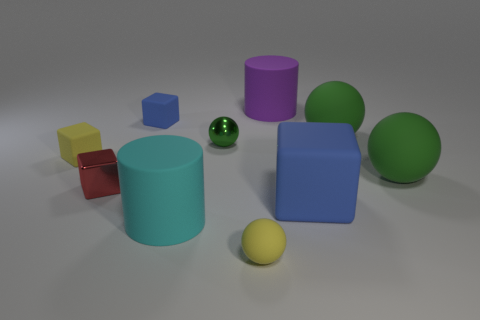How many other large spheres are the same color as the metal sphere?
Offer a terse response. 2. Are there any yellow objects that have the same shape as the tiny blue matte thing?
Your response must be concise. Yes. There is a big object that is both behind the red block and left of the big matte cube; what shape is it?
Make the answer very short. Cylinder. Are the big purple thing and the large cyan thing that is to the right of the small yellow matte block made of the same material?
Provide a short and direct response. Yes. There is a tiny blue cube; are there any tiny blue things in front of it?
Your response must be concise. No. What number of things are large cyan rubber cubes or tiny green things that are behind the cyan matte cylinder?
Make the answer very short. 1. There is a tiny matte block behind the green thing left of the big purple object; what is its color?
Offer a very short reply. Blue. How many other things are the same material as the big cube?
Offer a very short reply. 7. How many shiny objects are either cyan things or large purple cylinders?
Offer a terse response. 0. There is another small shiny object that is the same shape as the tiny blue thing; what is its color?
Your response must be concise. Red. 